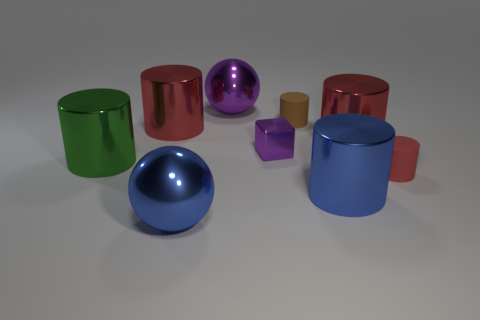Which objects in the image are the same color? None of the objects share an identical color; each item has its unique shade, offering a diverse palette. How does the difference in textures among the objects affect their appearance? The varying textures result in different ways the objects interact with light; smoother, reflective surfaces appear shinier, while the more matte textured objects have a softer look. 